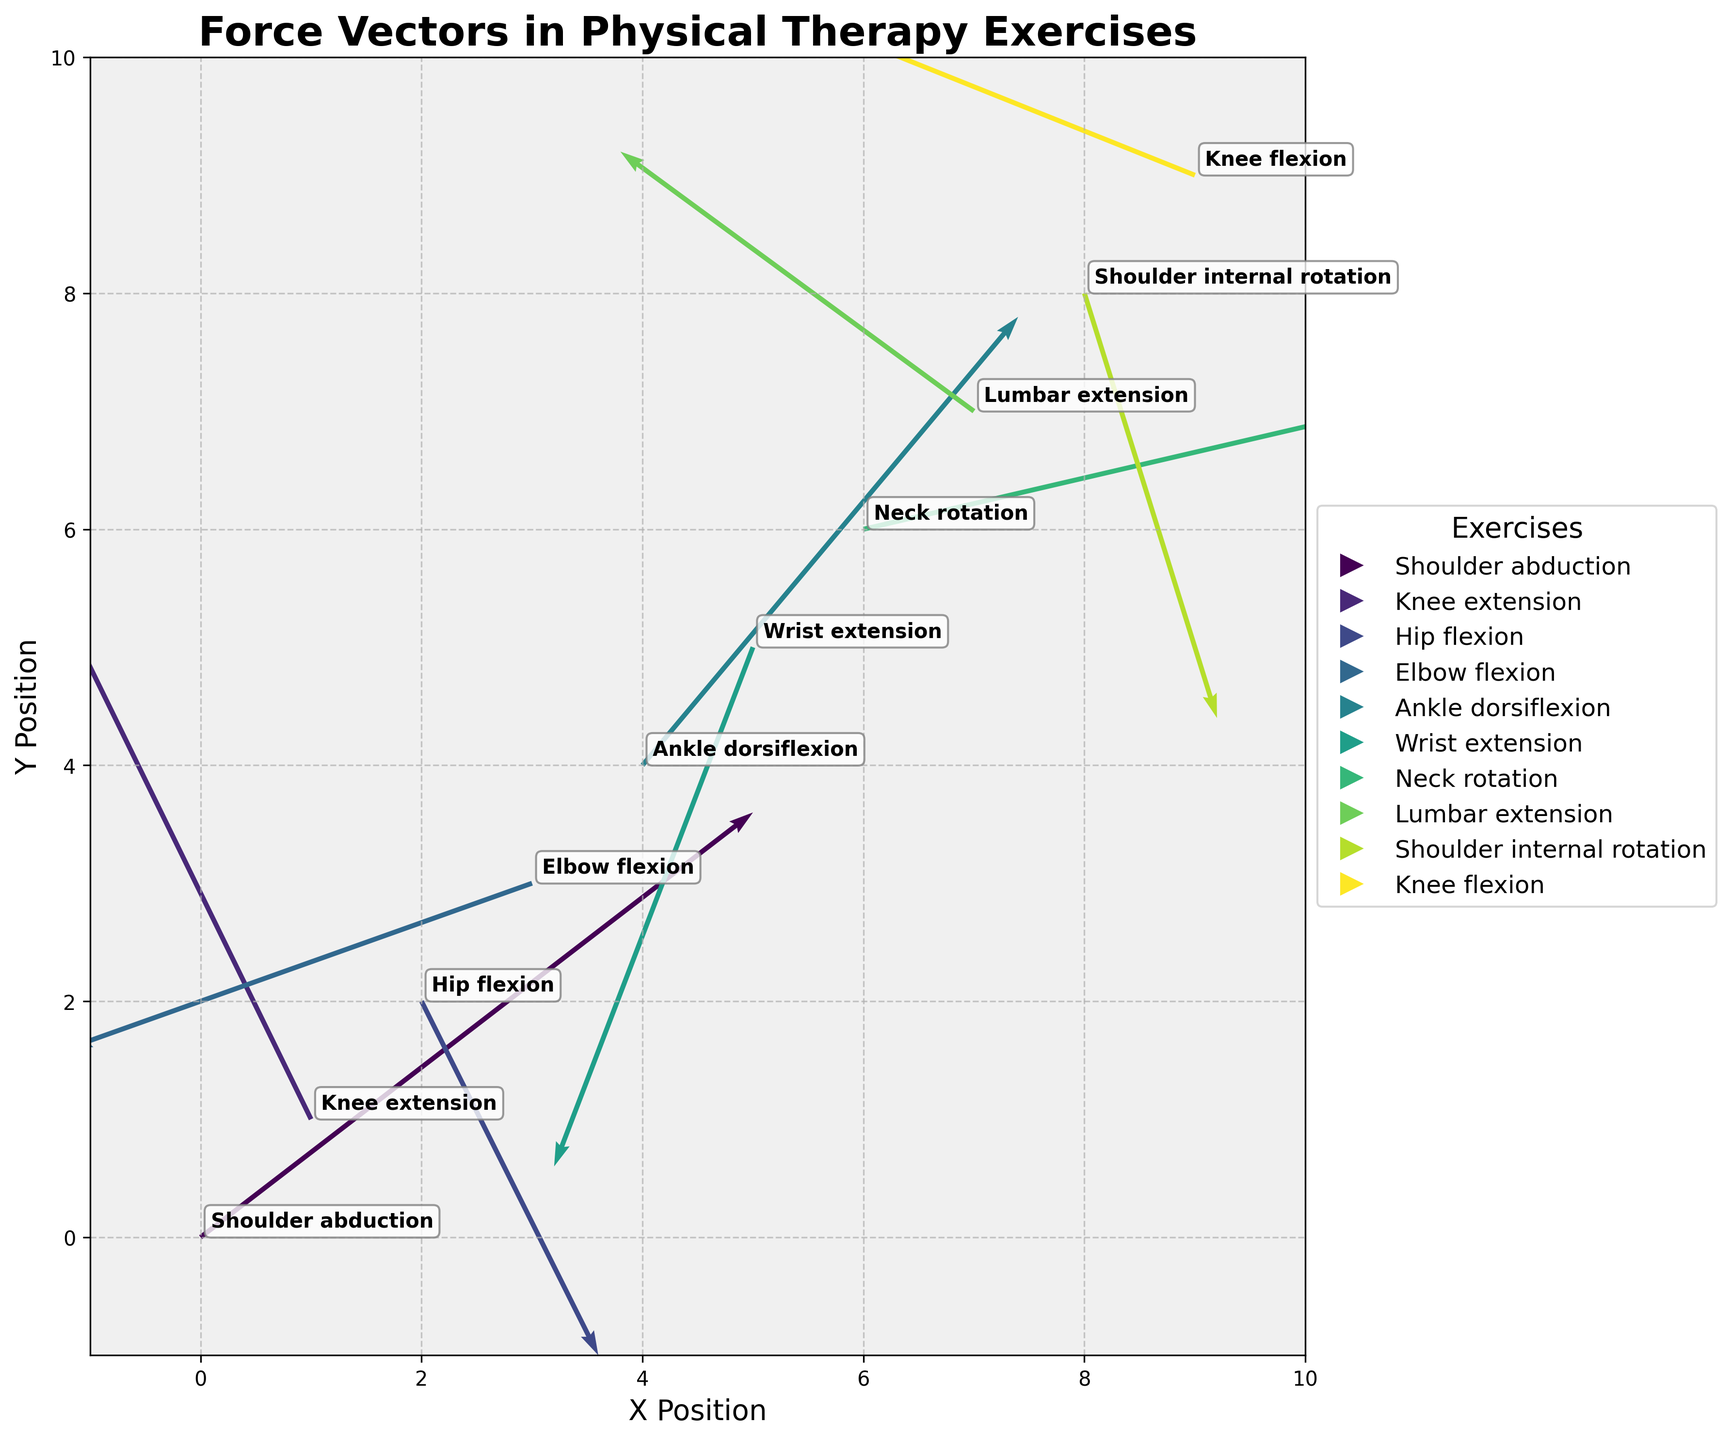How many force vectors are displayed in the plot? To answer, count the total number of vectors or arrows shown in the plot. Each vector represents one exercise.
Answer: 10 What exercise has the largest positive y-component of the force vector? Observe the vector component values on the plot, focusing on the positive y-components. The largest one appears at (1, 1) with a value of 2.3 corresponding to Knee extension.
Answer: Knee extension Which exercise force vector is located at (4, 4)? Identify the vector positioned at coordinates (4, 4) on the plot and find the corresponding exercise label in the annotated box.
Answer: Ankle dorsiflexion Compare the force vectors for Shoulder abduction and Knee flexion. Which one has a greater x-component? Look at the force vectors for both exercises (0, 0) for Shoulder abduction and (9, 9) for Knee flexion. Compare their x-components: 2.5 for Shoulder abduction and -2.4 for Knee flexion.
Answer: Shoulder abduction Which exercise force vector points predominantly in the negative y-direction? Examine the y-components of each force vector, looking for the largest negative value. The vector at (5, 5) for Wrist extension has a -2.2 y-component.
Answer: Wrist extension What are the color codes or patterns representing the exercises in the legend? The legend's mappings reveal each exercise's specific color or pattern used for the vectors. Identify and describe these based on the plot.
Answer: Colors from viridis colormap Is there any exercise with a purely horizontal force vector (no y-component)? Check if any vector on the plot has a v-component of zero, indicating no vertical movement.
Answer: No Which exercise has the smallest magnitude force vector? Calculate vector magnitudes using the formula √(u² + v²) for all exercises and find the smallest one. For example, Hip flexion has a magnitude √(0.8² + -1.5²).
Answer: Hip flexion What is the average length of the force vectors for the plotted exercises? Calculate the magnitude for each vector using √(u² + v²), sum them up, and then divide by the number of vectors to get the average.
Answer: Average length needs manual calculation Compare vectors for Shoulder abduction and Elbow flexion. Which one results in a vector more towards the origin on subtraction? Subtract the components, (2.5 - -2.1) for x and (1.8 - -0.7) for y. Calculate the magnitude of the resulting vector. Do the same for Elbow flexion's reverse, comparing both results.
Answer: Requires specific calculation 